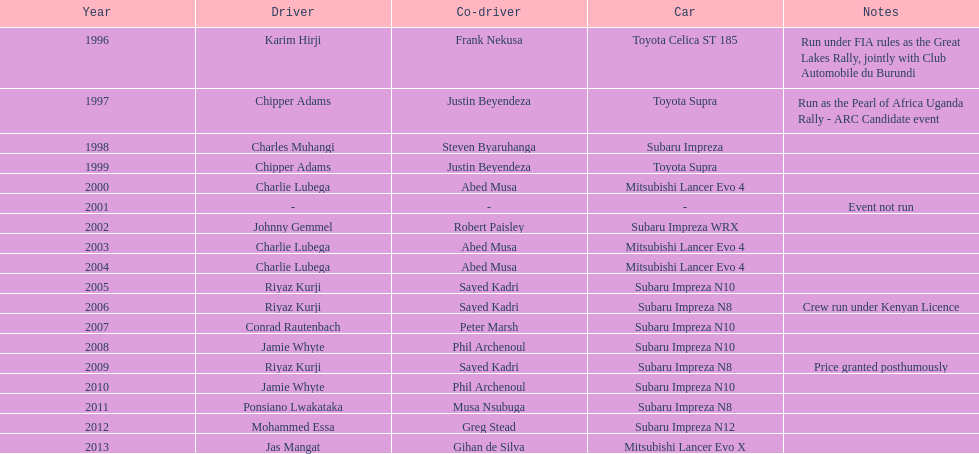How many times was a mitsubishi lancer the winning car before the year 2004? 2. 